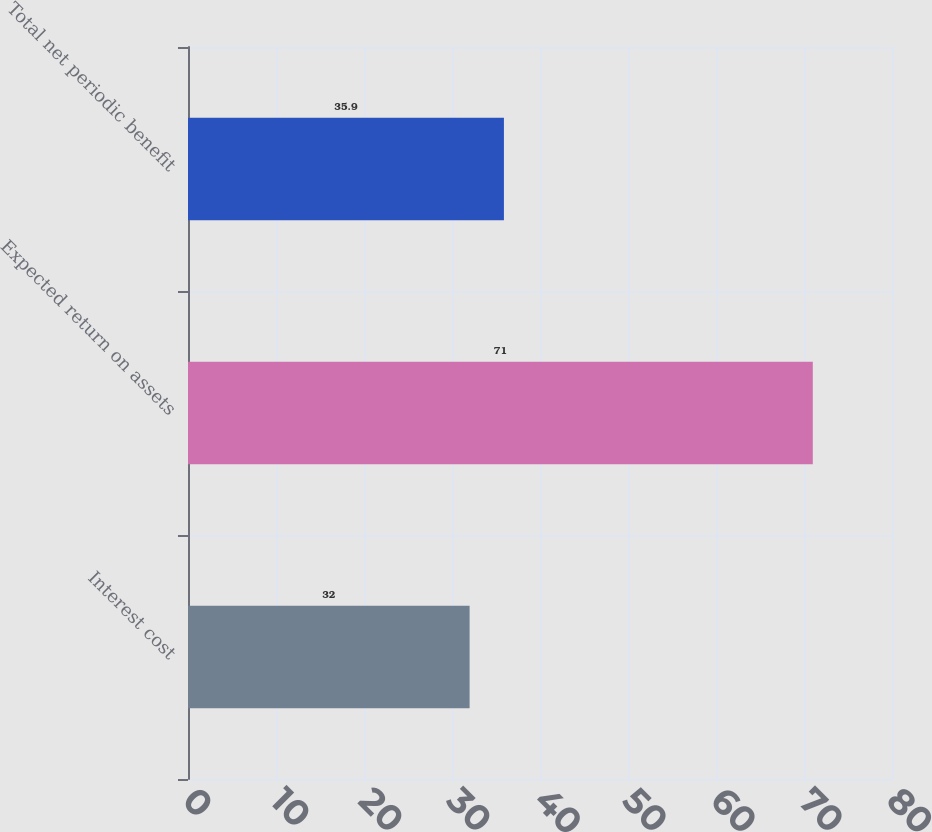<chart> <loc_0><loc_0><loc_500><loc_500><bar_chart><fcel>Interest cost<fcel>Expected return on assets<fcel>Total net periodic benefit<nl><fcel>32<fcel>71<fcel>35.9<nl></chart> 